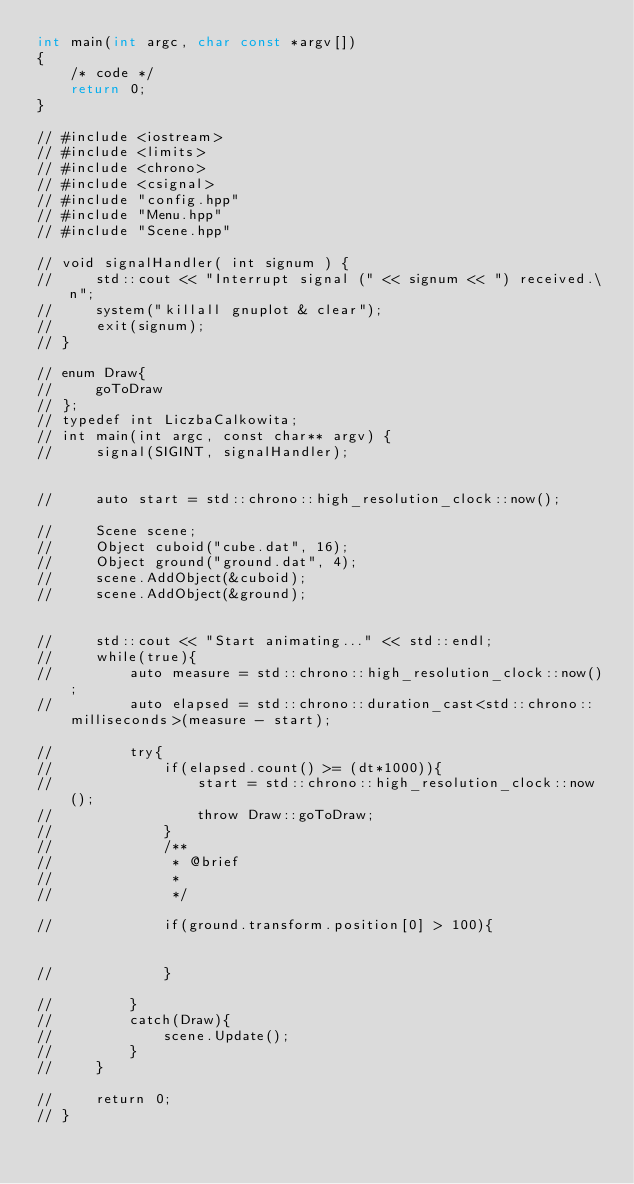<code> <loc_0><loc_0><loc_500><loc_500><_C++_>int main(int argc, char const *argv[])
{
    /* code */
    return 0;
}

// #include <iostream>
// #include <limits>
// #include <chrono>
// #include <csignal>
// #include "config.hpp"
// #include "Menu.hpp"
// #include "Scene.hpp"

// void signalHandler( int signum ) {
//     std::cout << "Interrupt signal (" << signum << ") received.\n";
//     system("killall gnuplot & clear");
//     exit(signum);  
// }

// enum Draw{
//     goToDraw
// };
// typedef int LiczbaCalkowita;
// int main(int argc, const char** argv) { 
//     signal(SIGINT, signalHandler);


//     auto start = std::chrono::high_resolution_clock::now();

//     Scene scene;
//     Object cuboid("cube.dat", 16);
//     Object ground("ground.dat", 4);
//     scene.AddObject(&cuboid);
//     scene.AddObject(&ground);
    

//     std::cout << "Start animating..." << std::endl;
//     while(true){
//         auto measure = std::chrono::high_resolution_clock::now();
//         auto elapsed = std::chrono::duration_cast<std::chrono::milliseconds>(measure - start);

//         try{
//             if(elapsed.count() >= (dt*1000)){
//                 start = std::chrono::high_resolution_clock::now();
//                 throw Draw::goToDraw;
//             }
//             /**
//              * @brief 
//              * 
//              */

//             if(ground.transform.position[0] > 100){
            
                
//             }

//         }
//         catch(Draw){
//             scene.Update();
//         }
//     }

//     return 0;
// }
</code> 